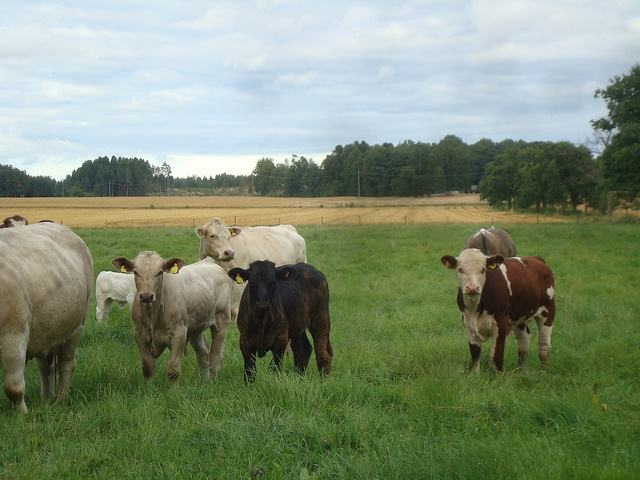Describe the objects in this image and their specific colors. I can see cow in lightblue, darkgray, gray, darkgreen, and black tones, cow in lightblue, darkgreen, gray, black, and darkgray tones, cow in lightblue, black, darkgreen, maroon, and gray tones, cow in lightblue, black, and darkgreen tones, and cow in lightblue, tan, and gray tones in this image. 